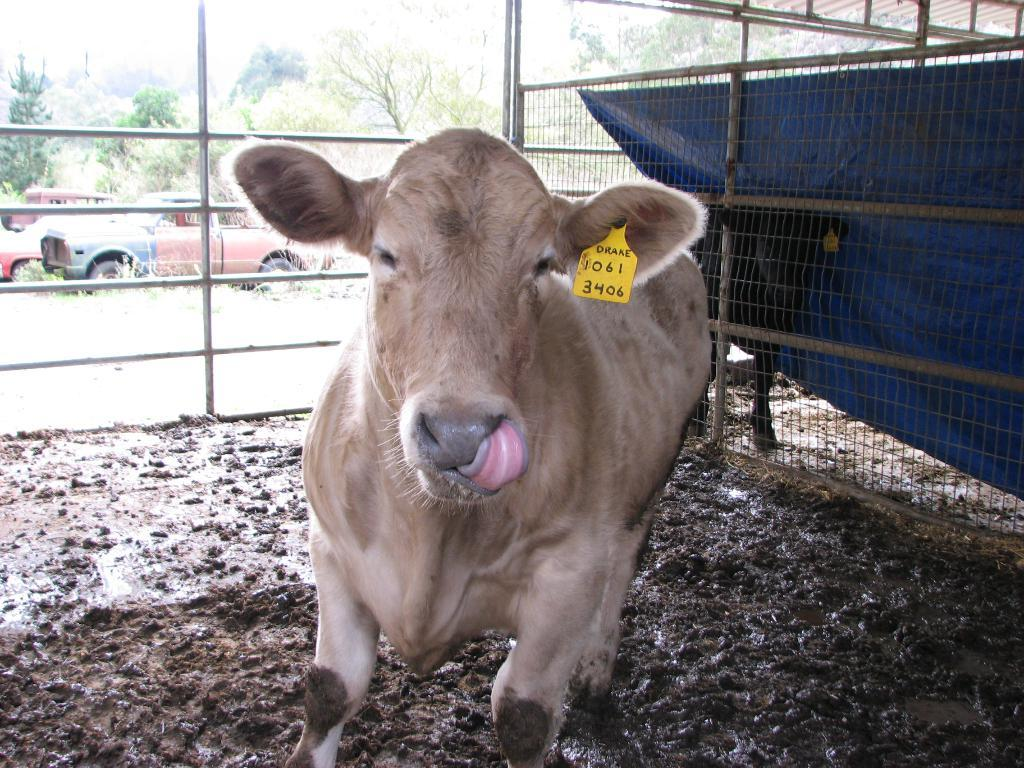What animal is present in the image? There is a calf in the image. Can you describe any identifying features of the calf? The calf has a tag on its ear. What type of terrain is the calf standing on? The calf is standing on mud land. What is surrounding the calf? The calf is inside a fence. What can be seen in the background of the image? There are vintage cars in the background of the image. What is located behind the vintage cars? The vintage cars are in front of trees. Can you tell me how many fairies are flying around the calf in the image? There are no fairies present in the image; it features a calf with a tag on its ear, standing on mud land inside a fence, with vintage cars and trees in the background. 